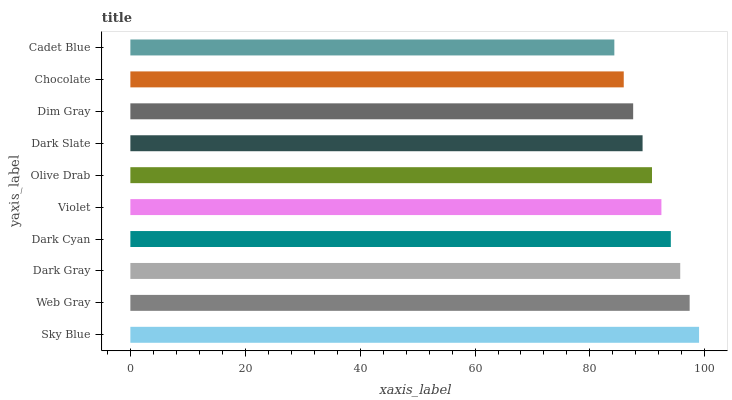Is Cadet Blue the minimum?
Answer yes or no. Yes. Is Sky Blue the maximum?
Answer yes or no. Yes. Is Web Gray the minimum?
Answer yes or no. No. Is Web Gray the maximum?
Answer yes or no. No. Is Sky Blue greater than Web Gray?
Answer yes or no. Yes. Is Web Gray less than Sky Blue?
Answer yes or no. Yes. Is Web Gray greater than Sky Blue?
Answer yes or no. No. Is Sky Blue less than Web Gray?
Answer yes or no. No. Is Violet the high median?
Answer yes or no. Yes. Is Olive Drab the low median?
Answer yes or no. Yes. Is Dim Gray the high median?
Answer yes or no. No. Is Dark Slate the low median?
Answer yes or no. No. 